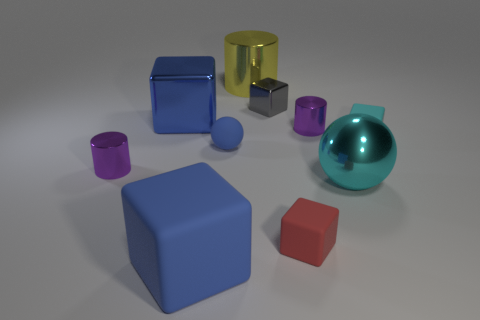Is the big shiny sphere the same color as the large shiny cylinder?
Keep it short and to the point. No. Do the sphere to the left of the big cyan metallic thing and the large yellow object that is behind the large shiny sphere have the same material?
Offer a terse response. No. Are any large cyan metal balls visible?
Your answer should be compact. Yes. There is a blue matte object that is in front of the large cyan metal object; is it the same shape as the big metal object that is left of the big metal cylinder?
Give a very brief answer. Yes. Is there a big brown block that has the same material as the small red cube?
Your answer should be very brief. No. Does the large object that is on the right side of the yellow shiny thing have the same material as the tiny red thing?
Provide a short and direct response. No. Is the number of large blue matte blocks behind the large metal block greater than the number of big things behind the gray metallic thing?
Your answer should be very brief. No. There is a shiny block that is the same size as the yellow cylinder; what color is it?
Your response must be concise. Blue. Are there any other blocks that have the same color as the big metallic cube?
Provide a short and direct response. Yes. There is a metallic block on the left side of the small blue rubber thing; is it the same color as the matte cube that is to the left of the gray thing?
Keep it short and to the point. Yes. 